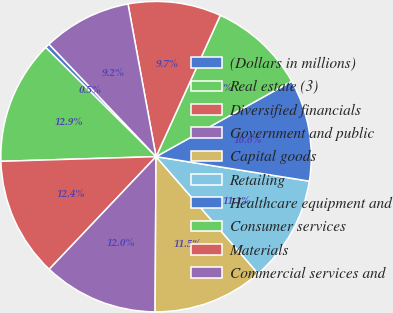<chart> <loc_0><loc_0><loc_500><loc_500><pie_chart><fcel>(Dollars in millions)<fcel>Real estate (3)<fcel>Diversified financials<fcel>Government and public<fcel>Capital goods<fcel>Retailing<fcel>Healthcare equipment and<fcel>Consumer services<fcel>Materials<fcel>Commercial services and<nl><fcel>0.47%<fcel>12.9%<fcel>12.44%<fcel>11.98%<fcel>11.52%<fcel>11.06%<fcel>10.6%<fcel>10.14%<fcel>9.68%<fcel>9.22%<nl></chart> 